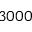Convert formula to latex. <formula><loc_0><loc_0><loc_500><loc_500>3 0 0 0</formula> 